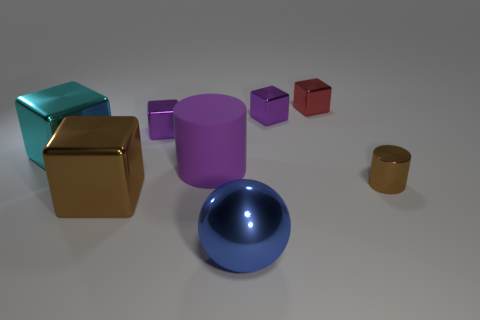Subtract all purple cubes. How many were subtracted if there are1purple cubes left? 1 Subtract 2 cubes. How many cubes are left? 3 Subtract all brown cubes. How many cubes are left? 4 Subtract all tiny red metallic blocks. How many blocks are left? 4 Subtract all gray blocks. Subtract all purple cylinders. How many blocks are left? 5 Add 1 red shiny objects. How many objects exist? 9 Subtract all cylinders. How many objects are left? 6 Subtract all cyan matte things. Subtract all large cyan metal things. How many objects are left? 7 Add 7 cyan shiny objects. How many cyan shiny objects are left? 8 Add 2 large cylinders. How many large cylinders exist? 3 